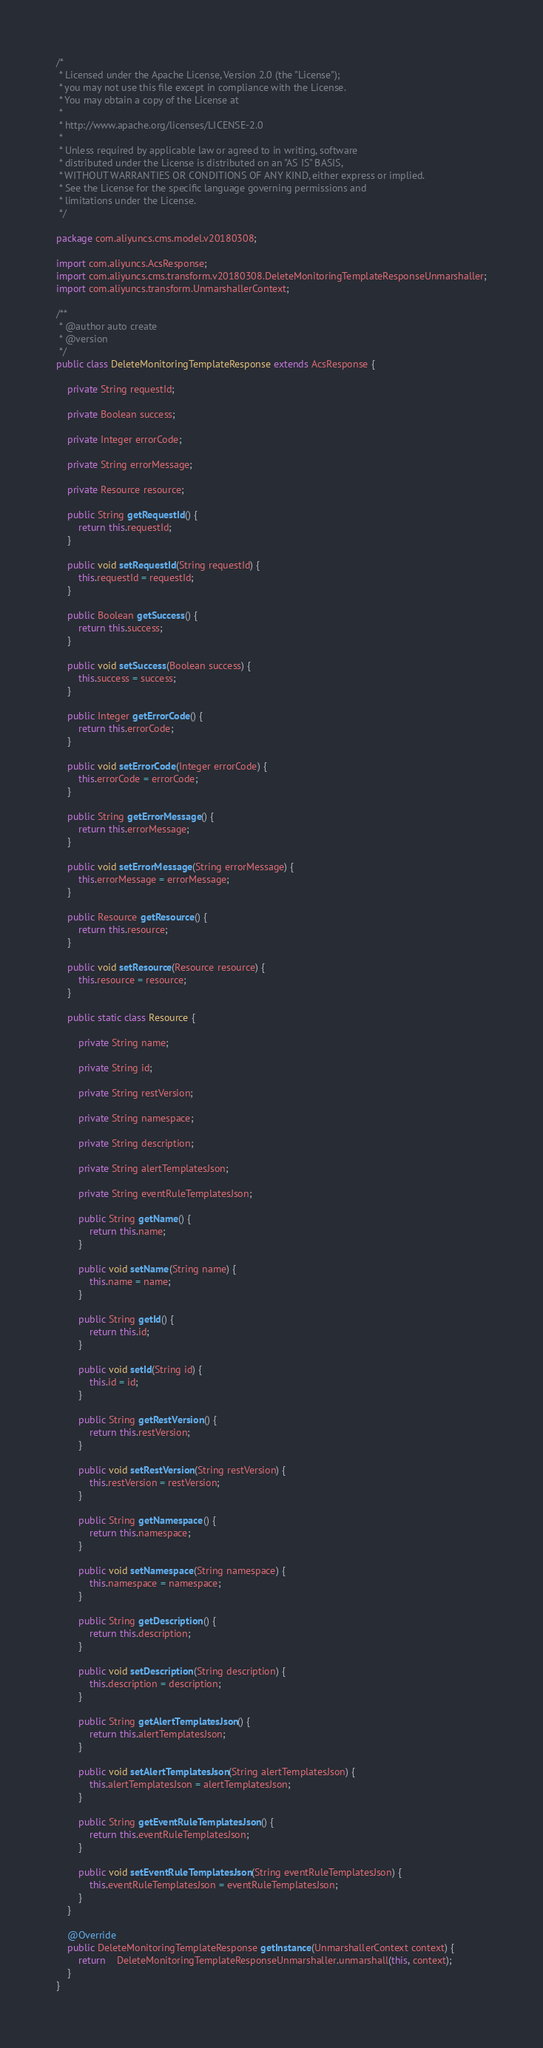<code> <loc_0><loc_0><loc_500><loc_500><_Java_>/*
 * Licensed under the Apache License, Version 2.0 (the "License");
 * you may not use this file except in compliance with the License.
 * You may obtain a copy of the License at
 *
 * http://www.apache.org/licenses/LICENSE-2.0
 *
 * Unless required by applicable law or agreed to in writing, software
 * distributed under the License is distributed on an "AS IS" BASIS,
 * WITHOUT WARRANTIES OR CONDITIONS OF ANY KIND, either express or implied.
 * See the License for the specific language governing permissions and
 * limitations under the License.
 */

package com.aliyuncs.cms.model.v20180308;

import com.aliyuncs.AcsResponse;
import com.aliyuncs.cms.transform.v20180308.DeleteMonitoringTemplateResponseUnmarshaller;
import com.aliyuncs.transform.UnmarshallerContext;

/**
 * @author auto create
 * @version 
 */
public class DeleteMonitoringTemplateResponse extends AcsResponse {

	private String requestId;

	private Boolean success;

	private Integer errorCode;

	private String errorMessage;

	private Resource resource;

	public String getRequestId() {
		return this.requestId;
	}

	public void setRequestId(String requestId) {
		this.requestId = requestId;
	}

	public Boolean getSuccess() {
		return this.success;
	}

	public void setSuccess(Boolean success) {
		this.success = success;
	}

	public Integer getErrorCode() {
		return this.errorCode;
	}

	public void setErrorCode(Integer errorCode) {
		this.errorCode = errorCode;
	}

	public String getErrorMessage() {
		return this.errorMessage;
	}

	public void setErrorMessage(String errorMessage) {
		this.errorMessage = errorMessage;
	}

	public Resource getResource() {
		return this.resource;
	}

	public void setResource(Resource resource) {
		this.resource = resource;
	}

	public static class Resource {

		private String name;

		private String id;

		private String restVersion;

		private String namespace;

		private String description;

		private String alertTemplatesJson;

		private String eventRuleTemplatesJson;

		public String getName() {
			return this.name;
		}

		public void setName(String name) {
			this.name = name;
		}

		public String getId() {
			return this.id;
		}

		public void setId(String id) {
			this.id = id;
		}

		public String getRestVersion() {
			return this.restVersion;
		}

		public void setRestVersion(String restVersion) {
			this.restVersion = restVersion;
		}

		public String getNamespace() {
			return this.namespace;
		}

		public void setNamespace(String namespace) {
			this.namespace = namespace;
		}

		public String getDescription() {
			return this.description;
		}

		public void setDescription(String description) {
			this.description = description;
		}

		public String getAlertTemplatesJson() {
			return this.alertTemplatesJson;
		}

		public void setAlertTemplatesJson(String alertTemplatesJson) {
			this.alertTemplatesJson = alertTemplatesJson;
		}

		public String getEventRuleTemplatesJson() {
			return this.eventRuleTemplatesJson;
		}

		public void setEventRuleTemplatesJson(String eventRuleTemplatesJson) {
			this.eventRuleTemplatesJson = eventRuleTemplatesJson;
		}
	}

	@Override
	public DeleteMonitoringTemplateResponse getInstance(UnmarshallerContext context) {
		return	DeleteMonitoringTemplateResponseUnmarshaller.unmarshall(this, context);
	}
}
</code> 